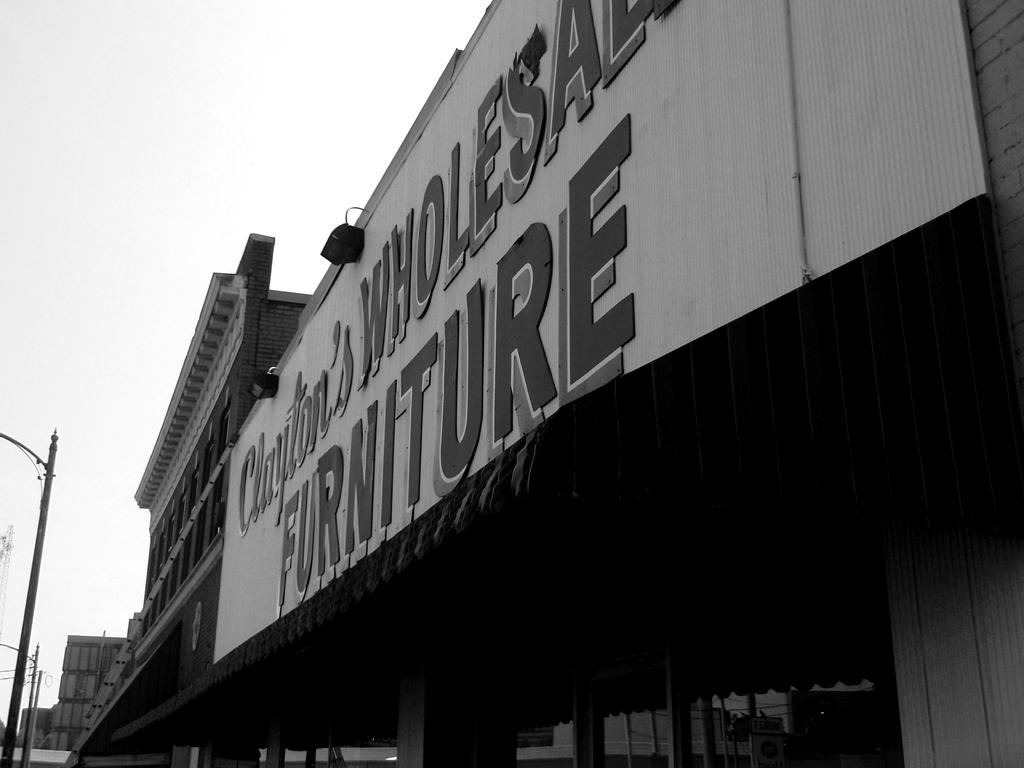What is the color scheme of the image? The image is black and white. What type of structures can be seen in the image? There are buildings in the image. What other objects are present in the image? There are poles, lights, and pillars in the image. What can be seen in the background of the image? The sky is visible in the background of the image. How many cherries are hanging from the tree in the image? There is no tree or cherries present in the image. What type of hall can be seen in the image? There is no hall present in the image. 